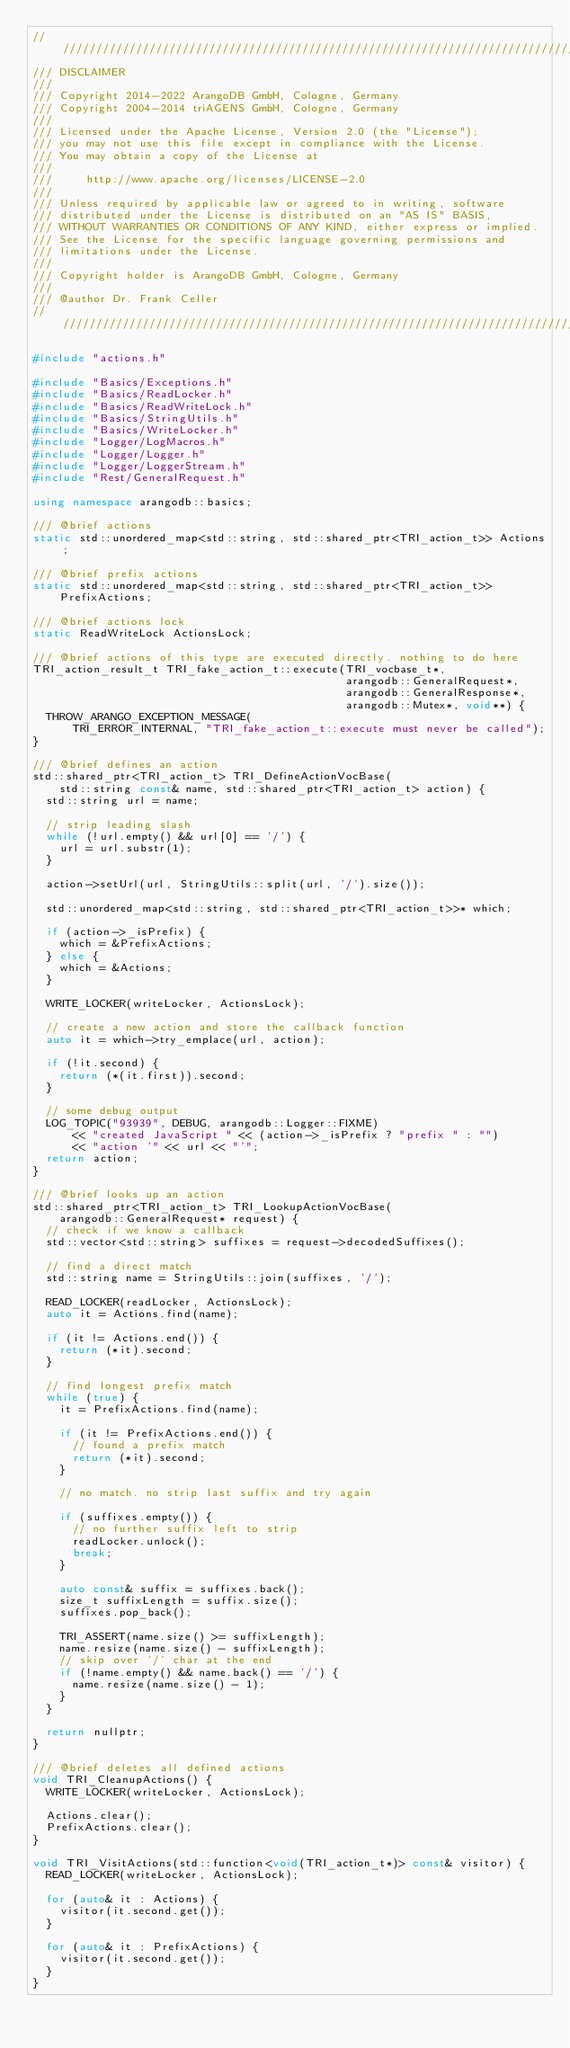<code> <loc_0><loc_0><loc_500><loc_500><_C++_>////////////////////////////////////////////////////////////////////////////////
/// DISCLAIMER
///
/// Copyright 2014-2022 ArangoDB GmbH, Cologne, Germany
/// Copyright 2004-2014 triAGENS GmbH, Cologne, Germany
///
/// Licensed under the Apache License, Version 2.0 (the "License");
/// you may not use this file except in compliance with the License.
/// You may obtain a copy of the License at
///
///     http://www.apache.org/licenses/LICENSE-2.0
///
/// Unless required by applicable law or agreed to in writing, software
/// distributed under the License is distributed on an "AS IS" BASIS,
/// WITHOUT WARRANTIES OR CONDITIONS OF ANY KIND, either express or implied.
/// See the License for the specific language governing permissions and
/// limitations under the License.
///
/// Copyright holder is ArangoDB GmbH, Cologne, Germany
///
/// @author Dr. Frank Celler
////////////////////////////////////////////////////////////////////////////////

#include "actions.h"

#include "Basics/Exceptions.h"
#include "Basics/ReadLocker.h"
#include "Basics/ReadWriteLock.h"
#include "Basics/StringUtils.h"
#include "Basics/WriteLocker.h"
#include "Logger/LogMacros.h"
#include "Logger/Logger.h"
#include "Logger/LoggerStream.h"
#include "Rest/GeneralRequest.h"

using namespace arangodb::basics;

/// @brief actions
static std::unordered_map<std::string, std::shared_ptr<TRI_action_t>> Actions;

/// @brief prefix actions
static std::unordered_map<std::string, std::shared_ptr<TRI_action_t>>
    PrefixActions;

/// @brief actions lock
static ReadWriteLock ActionsLock;

/// @brief actions of this type are executed directly. nothing to do here
TRI_action_result_t TRI_fake_action_t::execute(TRI_vocbase_t*,
                                               arangodb::GeneralRequest*,
                                               arangodb::GeneralResponse*,
                                               arangodb::Mutex*, void**) {
  THROW_ARANGO_EXCEPTION_MESSAGE(
      TRI_ERROR_INTERNAL, "TRI_fake_action_t::execute must never be called");
}

/// @brief defines an action
std::shared_ptr<TRI_action_t> TRI_DefineActionVocBase(
    std::string const& name, std::shared_ptr<TRI_action_t> action) {
  std::string url = name;

  // strip leading slash
  while (!url.empty() && url[0] == '/') {
    url = url.substr(1);
  }

  action->setUrl(url, StringUtils::split(url, '/').size());

  std::unordered_map<std::string, std::shared_ptr<TRI_action_t>>* which;

  if (action->_isPrefix) {
    which = &PrefixActions;
  } else {
    which = &Actions;
  }

  WRITE_LOCKER(writeLocker, ActionsLock);

  // create a new action and store the callback function
  auto it = which->try_emplace(url, action);

  if (!it.second) {
    return (*(it.first)).second;
  }

  // some debug output
  LOG_TOPIC("93939", DEBUG, arangodb::Logger::FIXME)
      << "created JavaScript " << (action->_isPrefix ? "prefix " : "")
      << "action '" << url << "'";
  return action;
}

/// @brief looks up an action
std::shared_ptr<TRI_action_t> TRI_LookupActionVocBase(
    arangodb::GeneralRequest* request) {
  // check if we know a callback
  std::vector<std::string> suffixes = request->decodedSuffixes();

  // find a direct match
  std::string name = StringUtils::join(suffixes, '/');

  READ_LOCKER(readLocker, ActionsLock);
  auto it = Actions.find(name);

  if (it != Actions.end()) {
    return (*it).second;
  }

  // find longest prefix match
  while (true) {
    it = PrefixActions.find(name);

    if (it != PrefixActions.end()) {
      // found a prefix match
      return (*it).second;
    }

    // no match. no strip last suffix and try again

    if (suffixes.empty()) {
      // no further suffix left to strip
      readLocker.unlock();
      break;
    }

    auto const& suffix = suffixes.back();
    size_t suffixLength = suffix.size();
    suffixes.pop_back();

    TRI_ASSERT(name.size() >= suffixLength);
    name.resize(name.size() - suffixLength);
    // skip over '/' char at the end
    if (!name.empty() && name.back() == '/') {
      name.resize(name.size() - 1);
    }
  }

  return nullptr;
}

/// @brief deletes all defined actions
void TRI_CleanupActions() {
  WRITE_LOCKER(writeLocker, ActionsLock);

  Actions.clear();
  PrefixActions.clear();
}

void TRI_VisitActions(std::function<void(TRI_action_t*)> const& visitor) {
  READ_LOCKER(writeLocker, ActionsLock);

  for (auto& it : Actions) {
    visitor(it.second.get());
  }

  for (auto& it : PrefixActions) {
    visitor(it.second.get());
  }
}
</code> 